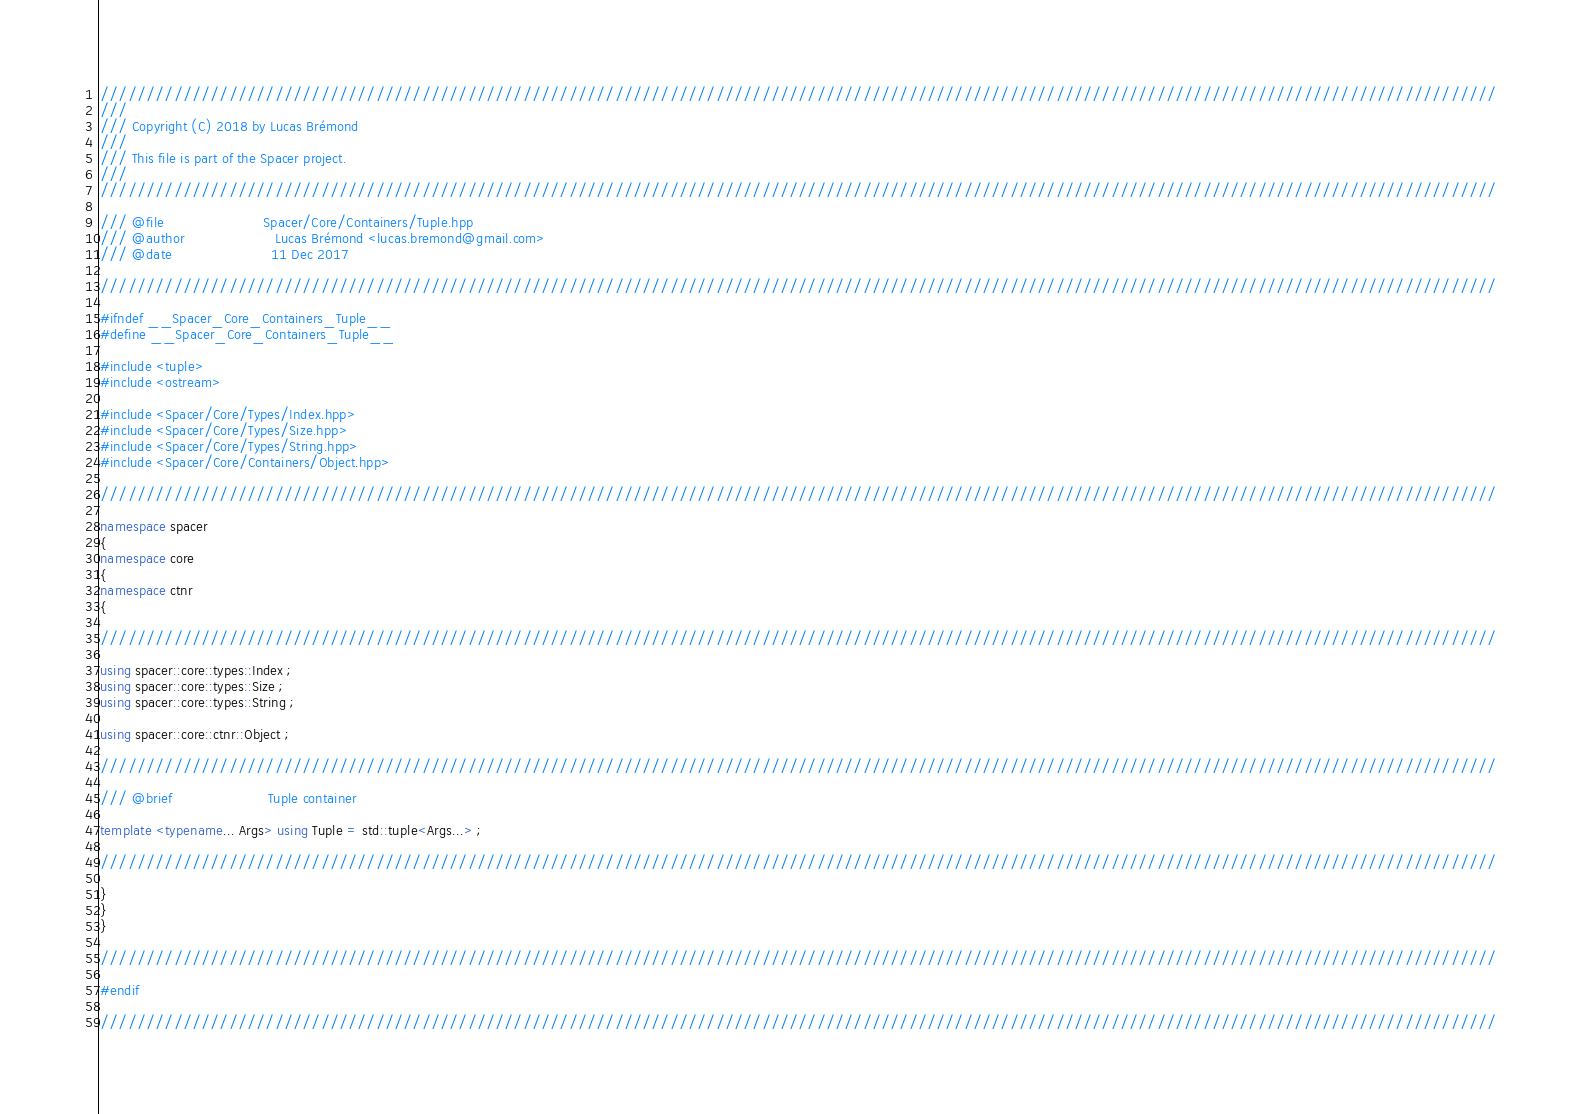<code> <loc_0><loc_0><loc_500><loc_500><_C++_>////////////////////////////////////////////////////////////////////////////////////////////////////////////////////////////////////////////////////////
///
/// Copyright (C) 2018 by Lucas Brémond
///
/// This file is part of the Spacer project.
///
////////////////////////////////////////////////////////////////////////////////////////////////////////////////////////////////////////////////////////

/// @file                       Spacer/Core/Containers/Tuple.hpp
/// @author                     Lucas Brémond <lucas.bremond@gmail.com>
/// @date                       11 Dec 2017

////////////////////////////////////////////////////////////////////////////////////////////////////////////////////////////////////////////////////////

#ifndef __Spacer_Core_Containers_Tuple__
#define __Spacer_Core_Containers_Tuple__

#include <tuple>
#include <ostream>

#include <Spacer/Core/Types/Index.hpp>
#include <Spacer/Core/Types/Size.hpp>
#include <Spacer/Core/Types/String.hpp>
#include <Spacer/Core/Containers/Object.hpp>

////////////////////////////////////////////////////////////////////////////////////////////////////////////////////////////////////////////////////////

namespace spacer
{
namespace core
{
namespace ctnr
{

////////////////////////////////////////////////////////////////////////////////////////////////////////////////////////////////////////////////////////

using spacer::core::types::Index ;
using spacer::core::types::Size ;
using spacer::core::types::String ;

using spacer::core::ctnr::Object ;

////////////////////////////////////////////////////////////////////////////////////////////////////////////////////////////////////////////////////////

/// @brief                      Tuple container

template <typename... Args> using Tuple = std::tuple<Args...> ;

////////////////////////////////////////////////////////////////////////////////////////////////////////////////////////////////////////////////////////

}
}
}

////////////////////////////////////////////////////////////////////////////////////////////////////////////////////////////////////////////////////////

#endif

////////////////////////////////////////////////////////////////////////////////////////////////////////////////////////////////////////////////////////</code> 